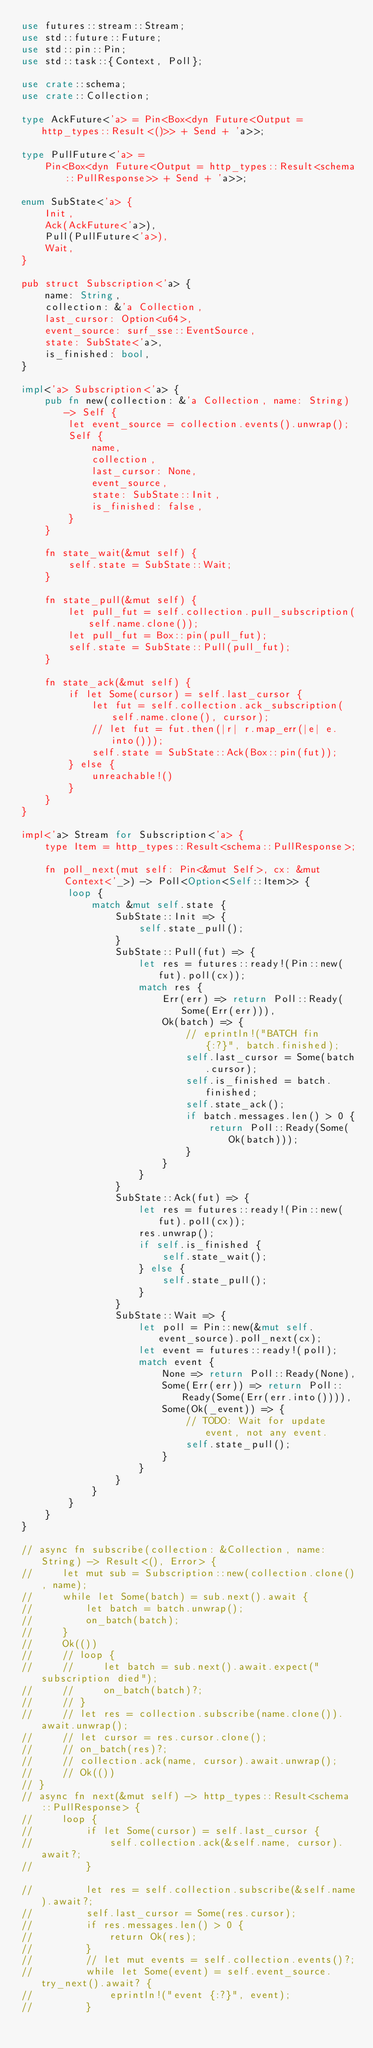Convert code to text. <code><loc_0><loc_0><loc_500><loc_500><_Rust_>use futures::stream::Stream;
use std::future::Future;
use std::pin::Pin;
use std::task::{Context, Poll};

use crate::schema;
use crate::Collection;

type AckFuture<'a> = Pin<Box<dyn Future<Output = http_types::Result<()>> + Send + 'a>>;

type PullFuture<'a> =
    Pin<Box<dyn Future<Output = http_types::Result<schema::PullResponse>> + Send + 'a>>;

enum SubState<'a> {
    Init,
    Ack(AckFuture<'a>),
    Pull(PullFuture<'a>),
    Wait,
}

pub struct Subscription<'a> {
    name: String,
    collection: &'a Collection,
    last_cursor: Option<u64>,
    event_source: surf_sse::EventSource,
    state: SubState<'a>,
    is_finished: bool,
}

impl<'a> Subscription<'a> {
    pub fn new(collection: &'a Collection, name: String) -> Self {
        let event_source = collection.events().unwrap();
        Self {
            name,
            collection,
            last_cursor: None,
            event_source,
            state: SubState::Init,
            is_finished: false,
        }
    }

    fn state_wait(&mut self) {
        self.state = SubState::Wait;
    }

    fn state_pull(&mut self) {
        let pull_fut = self.collection.pull_subscription(self.name.clone());
        let pull_fut = Box::pin(pull_fut);
        self.state = SubState::Pull(pull_fut);
    }

    fn state_ack(&mut self) {
        if let Some(cursor) = self.last_cursor {
            let fut = self.collection.ack_subscription(self.name.clone(), cursor);
            // let fut = fut.then(|r| r.map_err(|e| e.into()));
            self.state = SubState::Ack(Box::pin(fut));
        } else {
            unreachable!()
        }
    }
}

impl<'a> Stream for Subscription<'a> {
    type Item = http_types::Result<schema::PullResponse>;

    fn poll_next(mut self: Pin<&mut Self>, cx: &mut Context<'_>) -> Poll<Option<Self::Item>> {
        loop {
            match &mut self.state {
                SubState::Init => {
                    self.state_pull();
                }
                SubState::Pull(fut) => {
                    let res = futures::ready!(Pin::new(fut).poll(cx));
                    match res {
                        Err(err) => return Poll::Ready(Some(Err(err))),
                        Ok(batch) => {
                            // eprintln!("BATCH fin {:?}", batch.finished);
                            self.last_cursor = Some(batch.cursor);
                            self.is_finished = batch.finished;
                            self.state_ack();
                            if batch.messages.len() > 0 {
                                return Poll::Ready(Some(Ok(batch)));
                            }
                        }
                    }
                }
                SubState::Ack(fut) => {
                    let res = futures::ready!(Pin::new(fut).poll(cx));
                    res.unwrap();
                    if self.is_finished {
                        self.state_wait();
                    } else {
                        self.state_pull();
                    }
                }
                SubState::Wait => {
                    let poll = Pin::new(&mut self.event_source).poll_next(cx);
                    let event = futures::ready!(poll);
                    match event {
                        None => return Poll::Ready(None),
                        Some(Err(err)) => return Poll::Ready(Some(Err(err.into()))),
                        Some(Ok(_event)) => {
                            // TODO: Wait for update event, not any event.
                            self.state_pull();
                        }
                    }
                }
            }
        }
    }
}

// async fn subscribe(collection: &Collection, name: String) -> Result<(), Error> {
//     let mut sub = Subscription::new(collection.clone(), name);
//     while let Some(batch) = sub.next().await {
//         let batch = batch.unwrap();
//         on_batch(batch);
//     }
//     Ok(())
//     // loop {
//     //     let batch = sub.next().await.expect("subscription died");
//     //     on_batch(batch)?;
//     // }
//     // let res = collection.subscribe(name.clone()).await.unwrap();
//     // let cursor = res.cursor.clone();
//     // on_batch(res)?;
//     // collection.ack(name, cursor).await.unwrap();
//     // Ok(())
// }
// async fn next(&mut self) -> http_types::Result<schema::PullResponse> {
//     loop {
//         if let Some(cursor) = self.last_cursor {
//             self.collection.ack(&self.name, cursor).await?;
//         }

//         let res = self.collection.subscribe(&self.name).await?;
//         self.last_cursor = Some(res.cursor);
//         if res.messages.len() > 0 {
//             return Ok(res);
//         }
//         // let mut events = self.collection.events()?;
//         while let Some(event) = self.event_source.try_next().await? {
//             eprintln!("event {:?}", event);
//         }</code> 